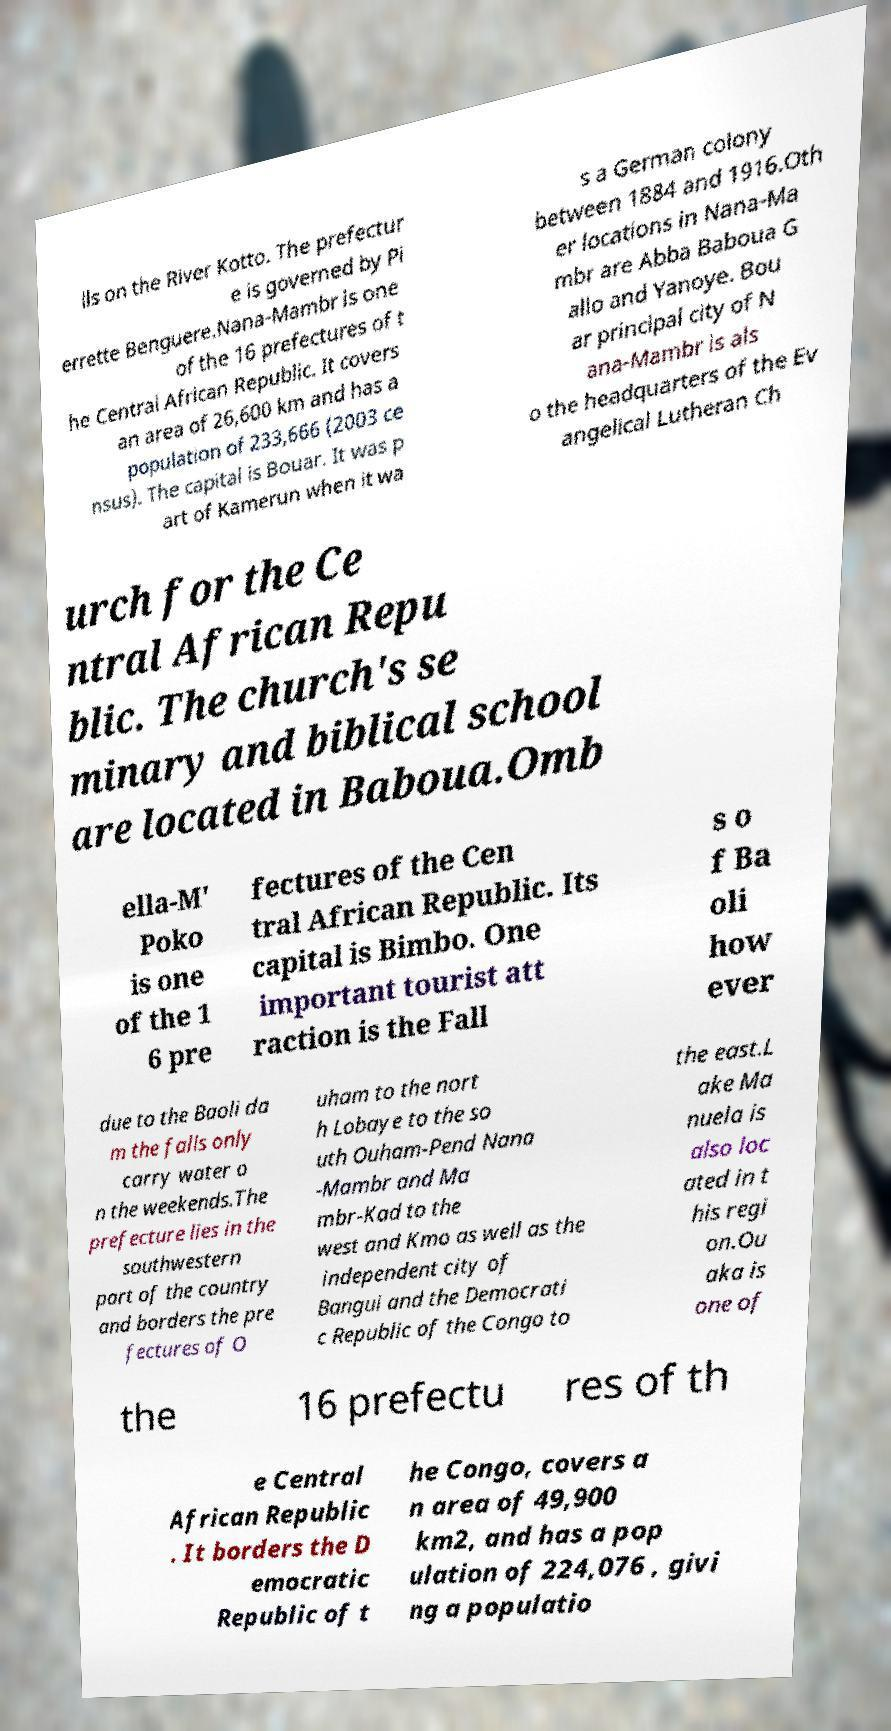What messages or text are displayed in this image? I need them in a readable, typed format. lls on the River Kotto. The prefectur e is governed by Pi errette Benguere.Nana-Mambr is one of the 16 prefectures of t he Central African Republic. It covers an area of 26,600 km and has a population of 233,666 (2003 ce nsus). The capital is Bouar. It was p art of Kamerun when it wa s a German colony between 1884 and 1916.Oth er locations in Nana-Ma mbr are Abba Baboua G allo and Yanoye. Bou ar principal city of N ana-Mambr is als o the headquarters of the Ev angelical Lutheran Ch urch for the Ce ntral African Repu blic. The church's se minary and biblical school are located in Baboua.Omb ella-M' Poko is one of the 1 6 pre fectures of the Cen tral African Republic. Its capital is Bimbo. One important tourist att raction is the Fall s o f Ba oli how ever due to the Baoli da m the falls only carry water o n the weekends.The prefecture lies in the southwestern part of the country and borders the pre fectures of O uham to the nort h Lobaye to the so uth Ouham-Pend Nana -Mambr and Ma mbr-Kad to the west and Kmo as well as the independent city of Bangui and the Democrati c Republic of the Congo to the east.L ake Ma nuela is also loc ated in t his regi on.Ou aka is one of the 16 prefectu res of th e Central African Republic . It borders the D emocratic Republic of t he Congo, covers a n area of 49,900 km2, and has a pop ulation of 224,076 , givi ng a populatio 